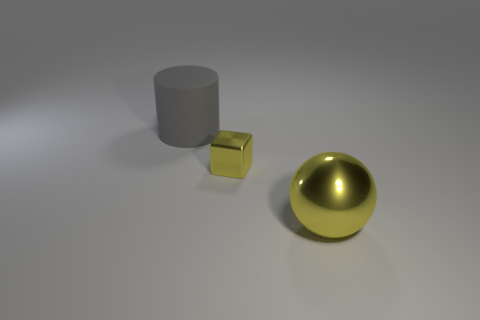Imagine these objects are part of a story. What could the narrative be? In a narrative context, these objects could symbolize different characters or elements within a story. The gray cylinder might represent a stoic character, unyielding and strong. The small cube could symbolize something precious or valuable, given its gold-like appearance. The shiny sphere might represent a source of wisdom or power, standing out with its glossy exterior. Together, they could be part of a tale about discovering one's worth and the differing roles individuals play in a community. 